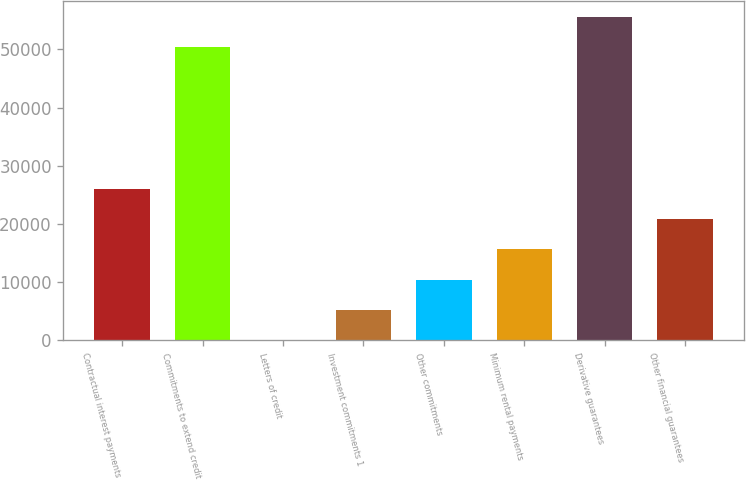<chart> <loc_0><loc_0><loc_500><loc_500><bar_chart><fcel>Contractual interest payments<fcel>Commitments to extend credit<fcel>Letters of credit<fcel>Investment commitments 1<fcel>Other commitments<fcel>Minimum rental payments<fcel>Derivative guarantees<fcel>Other financial guarantees<nl><fcel>25968.5<fcel>50423<fcel>10<fcel>5201.7<fcel>10393.4<fcel>15585.1<fcel>55614.7<fcel>20776.8<nl></chart> 